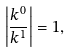<formula> <loc_0><loc_0><loc_500><loc_500>\left | \frac { k ^ { 0 } } { k ^ { 1 } } \right | = 1 ,</formula> 